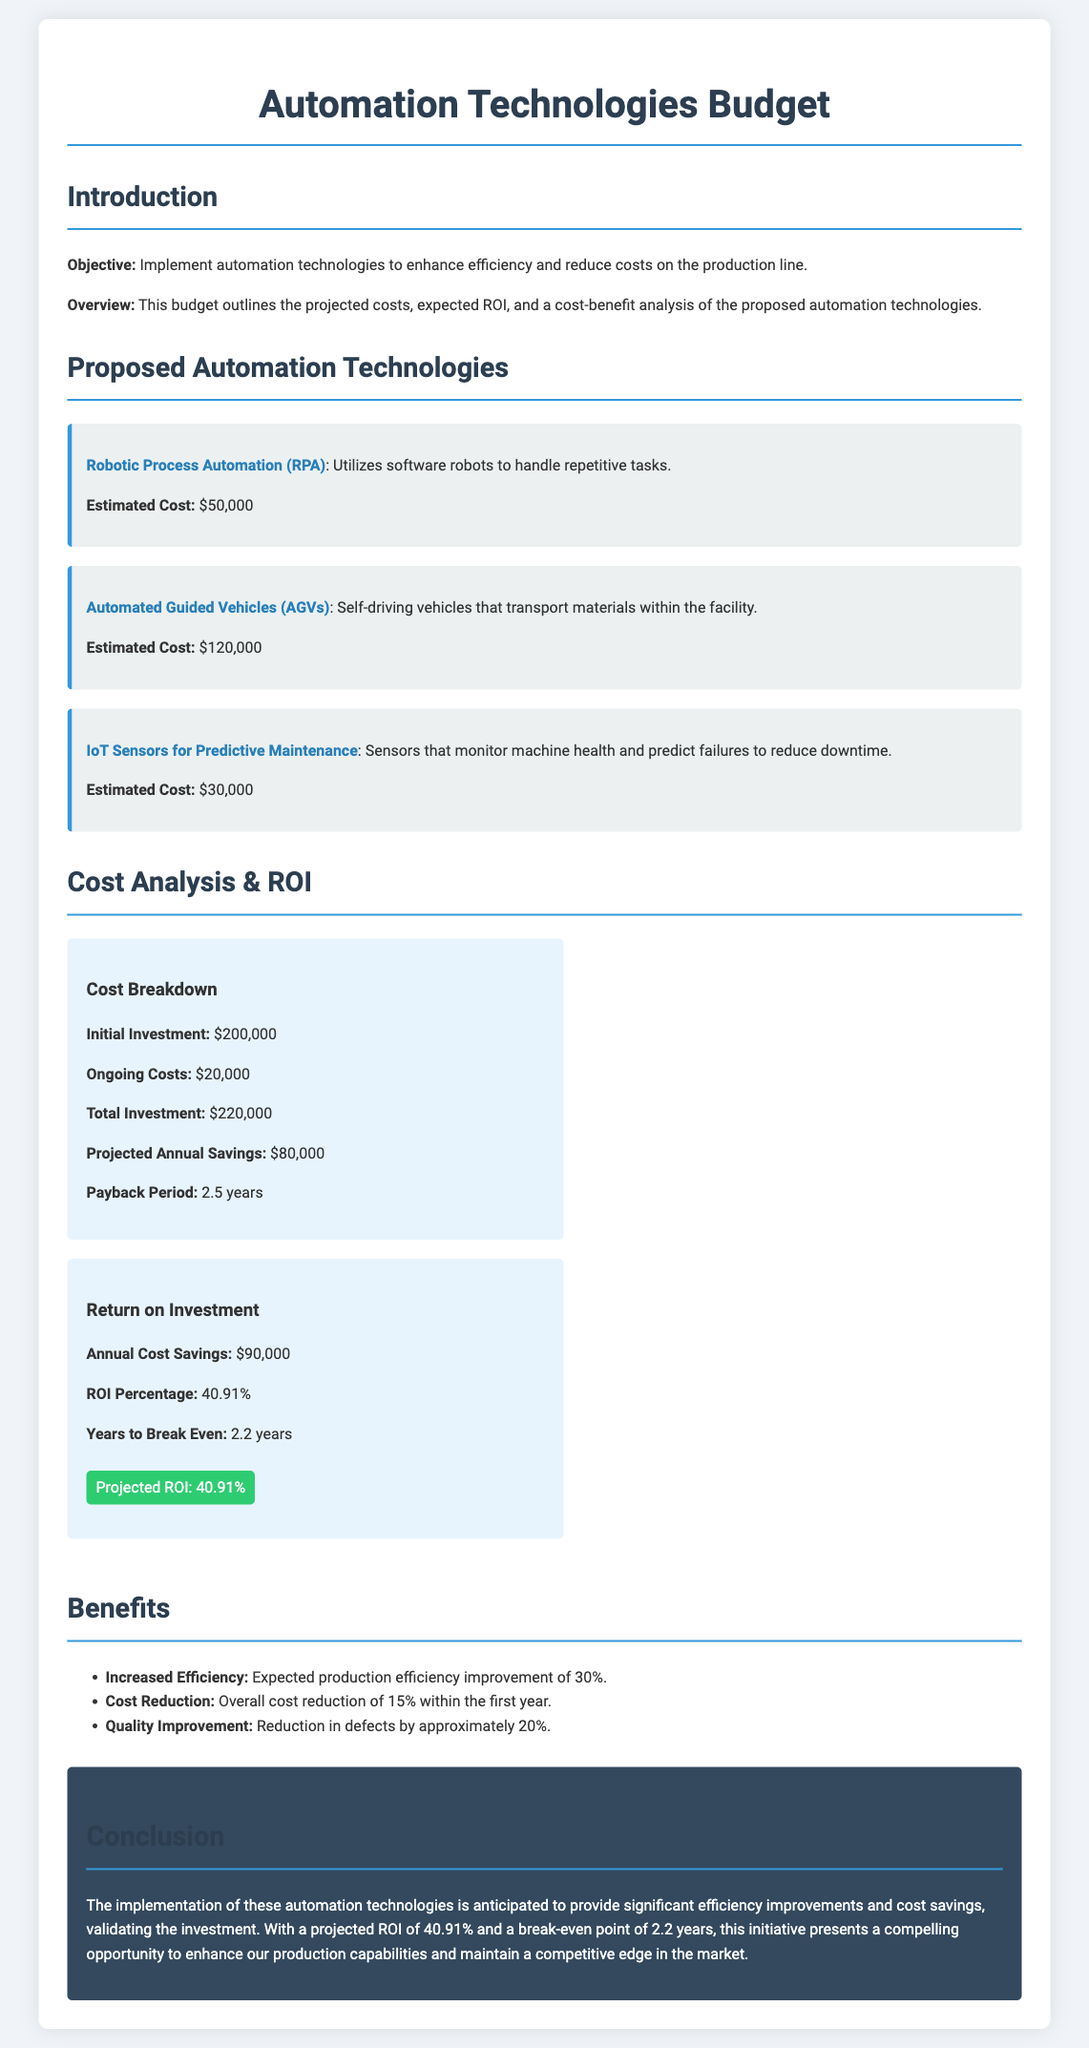What is the estimated cost of Robotic Process Automation? The estimated cost of Robotic Process Automation is listed in the document.
Answer: $50,000 What is the total investment for the automation technologies? The total investment is specified after calculating the initial and ongoing costs.
Answer: $220,000 What is the projected annual savings from the automation implementation? The projected annual savings are outlined in the cost analysis section.
Answer: $80,000 What is the break-even period for the investment? The break-even period is mentioned in the cost analysis details.
Answer: 2.2 years What percentage increase in efficiency is expected with automation? The expected production efficiency improvement is stated in the benefits section.
Answer: 30% What is the total estimated cost of Automated Guided Vehicles? The estimated cost for Automated Guided Vehicles appears in the proposed automation technologies section.
Answer: $120,000 What is the projected ROI percentage? The projected ROI percentage is provided within the return on investment section.
Answer: 40.91% What is the initial investment amount? The initial investment amount is listed in the cost analysis section.
Answer: $200,000 What reduction in defects is anticipated with automation? The expected reduction in defects is detailed in the benefits section.
Answer: 20% 